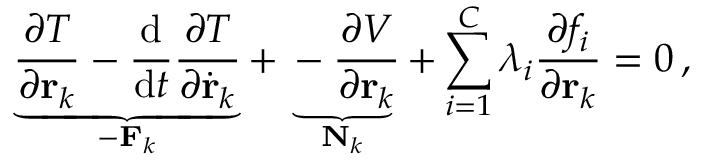Convert formula to latex. <formula><loc_0><loc_0><loc_500><loc_500>\underbrace { { \frac { \partial T } { \partial r _ { k } } } - { \frac { d } { d t } } { \frac { \partial T } { \partial { \dot { r } } _ { k } } } } _ { - F _ { k } } + \underbrace { - { \frac { \partial V } { \partial r _ { k } } } } _ { N _ { k } } + \sum _ { i = 1 } ^ { C } \lambda _ { i } { \frac { \partial f _ { i } } { \partial r _ { k } } } = 0 \, ,</formula> 